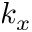Convert formula to latex. <formula><loc_0><loc_0><loc_500><loc_500>k _ { x }</formula> 